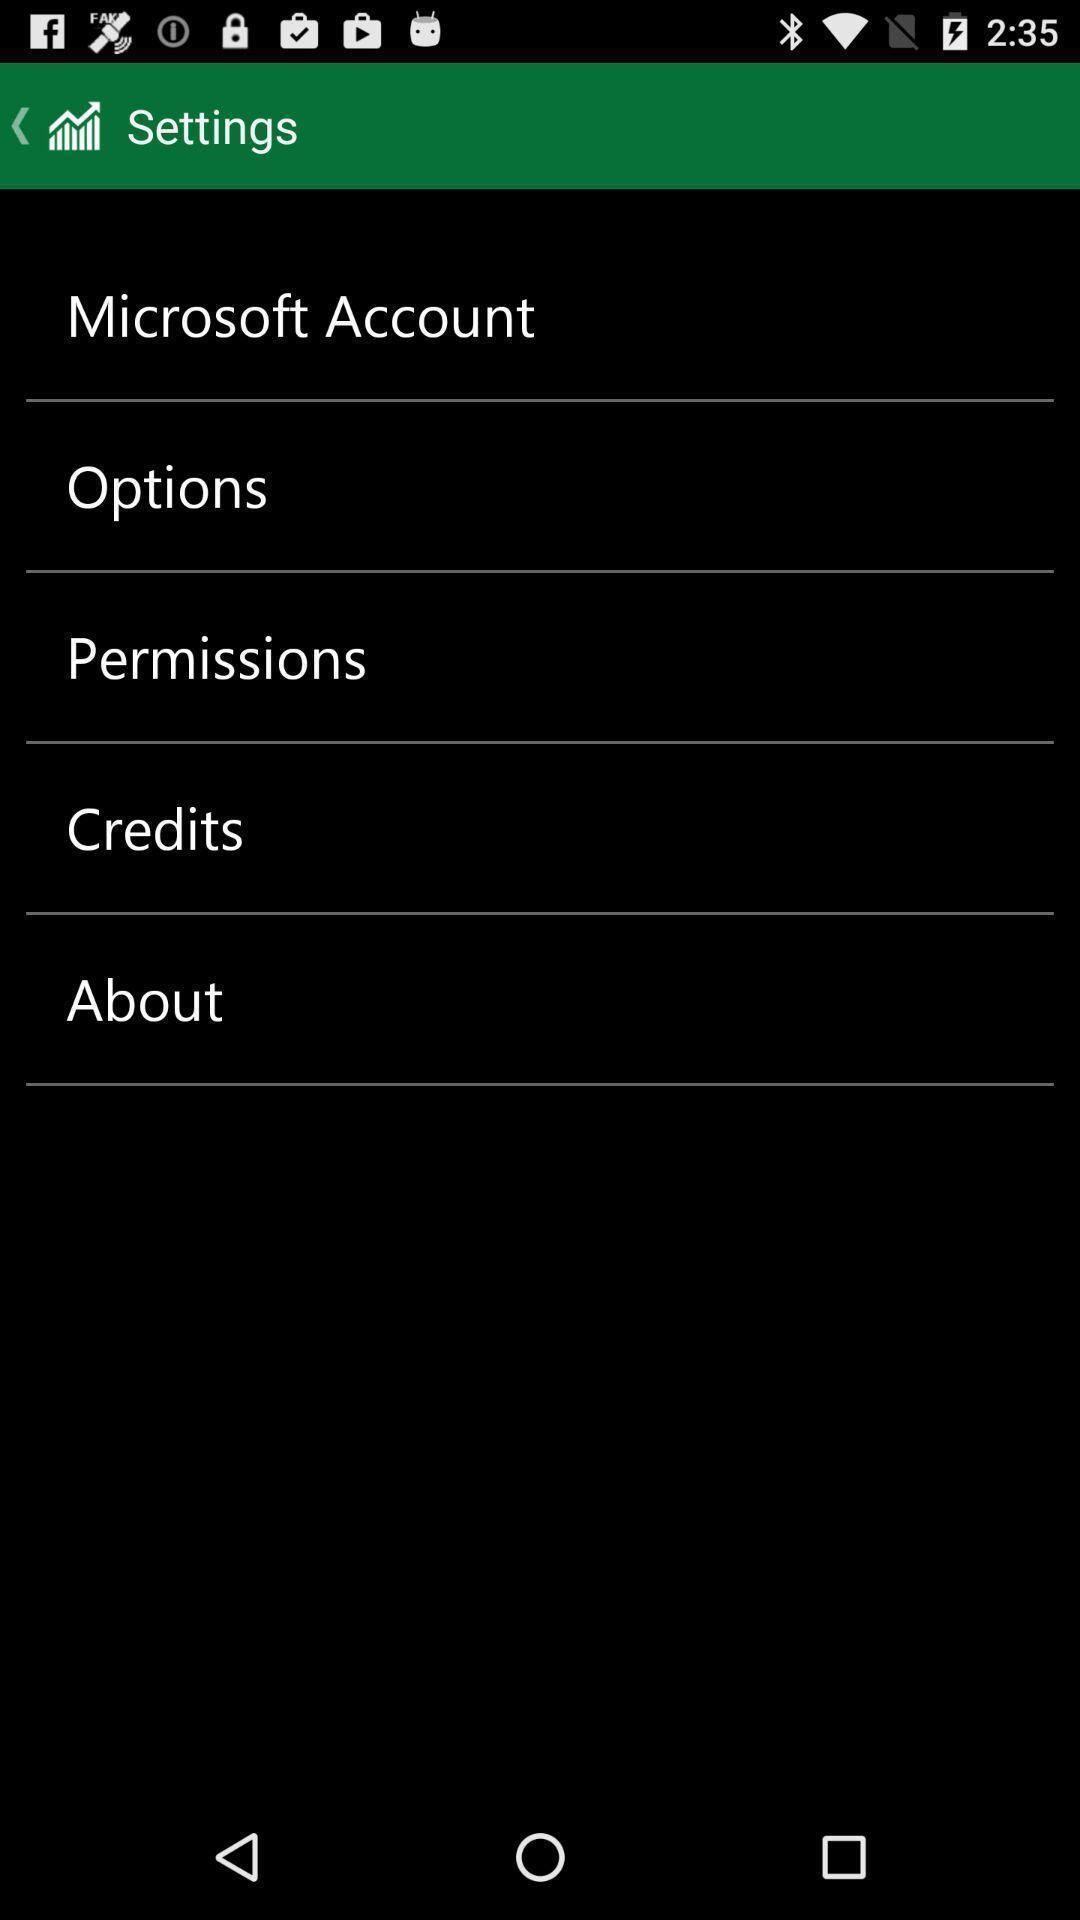Explain what's happening in this screen capture. Settings page. 